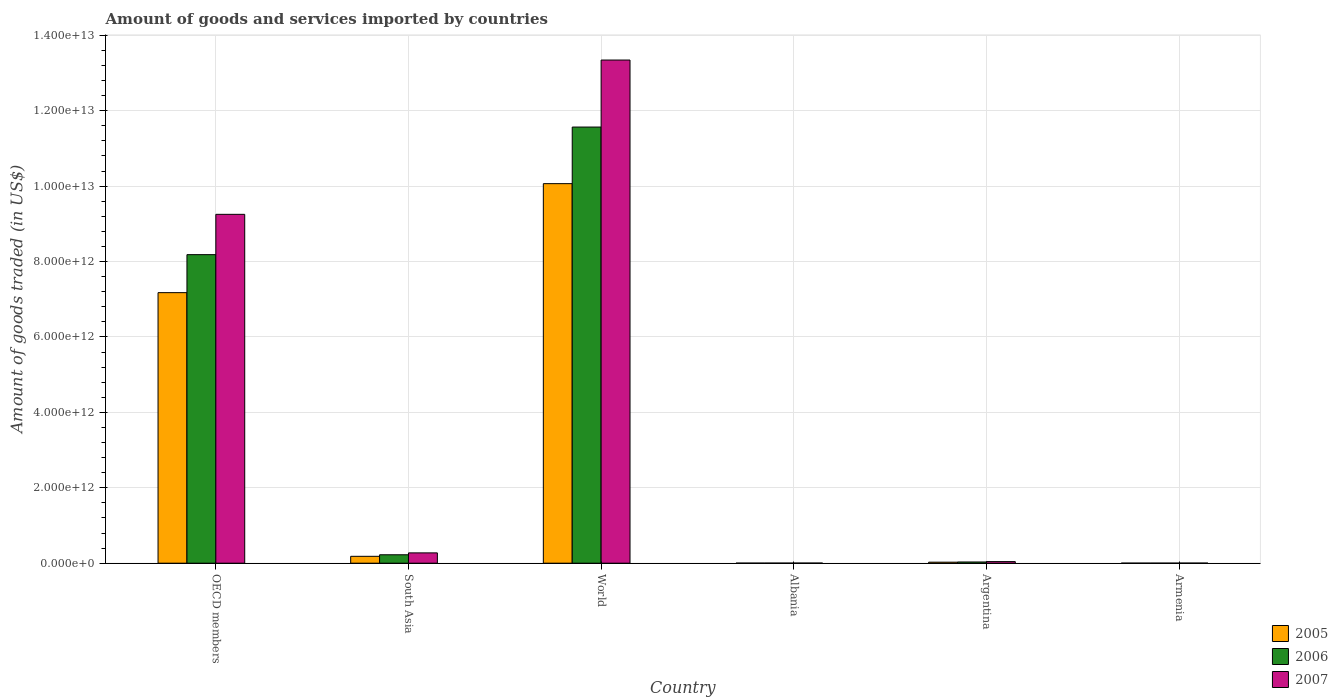How many bars are there on the 5th tick from the right?
Ensure brevity in your answer.  3. What is the label of the 4th group of bars from the left?
Give a very brief answer. Albania. In how many cases, is the number of bars for a given country not equal to the number of legend labels?
Your response must be concise. 0. What is the total amount of goods and services imported in 2007 in World?
Your answer should be compact. 1.33e+13. Across all countries, what is the maximum total amount of goods and services imported in 2007?
Provide a short and direct response. 1.33e+13. Across all countries, what is the minimum total amount of goods and services imported in 2007?
Keep it short and to the point. 2.92e+09. In which country was the total amount of goods and services imported in 2007 maximum?
Make the answer very short. World. In which country was the total amount of goods and services imported in 2007 minimum?
Ensure brevity in your answer.  Armenia. What is the total total amount of goods and services imported in 2005 in the graph?
Make the answer very short. 1.75e+13. What is the difference between the total amount of goods and services imported in 2007 in Albania and that in World?
Your answer should be compact. -1.33e+13. What is the difference between the total amount of goods and services imported in 2006 in Argentina and the total amount of goods and services imported in 2007 in South Asia?
Your answer should be very brief. -2.41e+11. What is the average total amount of goods and services imported in 2007 per country?
Your answer should be compact. 3.82e+12. What is the difference between the total amount of goods and services imported of/in 2005 and total amount of goods and services imported of/in 2006 in OECD members?
Keep it short and to the point. -1.01e+12. What is the ratio of the total amount of goods and services imported in 2006 in Albania to that in Argentina?
Provide a short and direct response. 0.08. Is the difference between the total amount of goods and services imported in 2005 in Argentina and South Asia greater than the difference between the total amount of goods and services imported in 2006 in Argentina and South Asia?
Keep it short and to the point. Yes. What is the difference between the highest and the second highest total amount of goods and services imported in 2005?
Ensure brevity in your answer.  -9.88e+12. What is the difference between the highest and the lowest total amount of goods and services imported in 2006?
Keep it short and to the point. 1.16e+13. Is the sum of the total amount of goods and services imported in 2005 in Argentina and Armenia greater than the maximum total amount of goods and services imported in 2007 across all countries?
Provide a short and direct response. No. Is it the case that in every country, the sum of the total amount of goods and services imported in 2005 and total amount of goods and services imported in 2007 is greater than the total amount of goods and services imported in 2006?
Give a very brief answer. Yes. What is the difference between two consecutive major ticks on the Y-axis?
Ensure brevity in your answer.  2.00e+12. Are the values on the major ticks of Y-axis written in scientific E-notation?
Give a very brief answer. Yes. Does the graph contain any zero values?
Offer a very short reply. No. Does the graph contain grids?
Keep it short and to the point. Yes. Where does the legend appear in the graph?
Keep it short and to the point. Bottom right. How many legend labels are there?
Your answer should be compact. 3. How are the legend labels stacked?
Offer a terse response. Vertical. What is the title of the graph?
Offer a terse response. Amount of goods and services imported by countries. What is the label or title of the Y-axis?
Give a very brief answer. Amount of goods traded (in US$). What is the Amount of goods traded (in US$) in 2005 in OECD members?
Your answer should be very brief. 7.18e+12. What is the Amount of goods traded (in US$) in 2006 in OECD members?
Make the answer very short. 8.18e+12. What is the Amount of goods traded (in US$) of 2007 in OECD members?
Offer a terse response. 9.25e+12. What is the Amount of goods traded (in US$) of 2005 in South Asia?
Ensure brevity in your answer.  1.83e+11. What is the Amount of goods traded (in US$) in 2006 in South Asia?
Ensure brevity in your answer.  2.24e+11. What is the Amount of goods traded (in US$) of 2007 in South Asia?
Offer a very short reply. 2.74e+11. What is the Amount of goods traded (in US$) of 2005 in World?
Provide a succinct answer. 1.01e+13. What is the Amount of goods traded (in US$) of 2006 in World?
Your answer should be compact. 1.16e+13. What is the Amount of goods traded (in US$) in 2007 in World?
Offer a very short reply. 1.33e+13. What is the Amount of goods traded (in US$) of 2005 in Albania?
Provide a succinct answer. 2.12e+09. What is the Amount of goods traded (in US$) of 2006 in Albania?
Keep it short and to the point. 2.50e+09. What is the Amount of goods traded (in US$) in 2007 in Albania?
Ensure brevity in your answer.  3.42e+09. What is the Amount of goods traded (in US$) of 2005 in Argentina?
Make the answer very short. 2.73e+1. What is the Amount of goods traded (in US$) in 2006 in Argentina?
Provide a succinct answer. 3.26e+1. What is the Amount of goods traded (in US$) of 2007 in Argentina?
Make the answer very short. 4.25e+1. What is the Amount of goods traded (in US$) in 2005 in Armenia?
Offer a terse response. 1.66e+09. What is the Amount of goods traded (in US$) in 2006 in Armenia?
Your answer should be very brief. 2.00e+09. What is the Amount of goods traded (in US$) of 2007 in Armenia?
Make the answer very short. 2.92e+09. Across all countries, what is the maximum Amount of goods traded (in US$) of 2005?
Provide a short and direct response. 1.01e+13. Across all countries, what is the maximum Amount of goods traded (in US$) of 2006?
Ensure brevity in your answer.  1.16e+13. Across all countries, what is the maximum Amount of goods traded (in US$) of 2007?
Your response must be concise. 1.33e+13. Across all countries, what is the minimum Amount of goods traded (in US$) of 2005?
Give a very brief answer. 1.66e+09. Across all countries, what is the minimum Amount of goods traded (in US$) of 2006?
Provide a succinct answer. 2.00e+09. Across all countries, what is the minimum Amount of goods traded (in US$) in 2007?
Provide a succinct answer. 2.92e+09. What is the total Amount of goods traded (in US$) of 2005 in the graph?
Give a very brief answer. 1.75e+13. What is the total Amount of goods traded (in US$) of 2006 in the graph?
Offer a terse response. 2.00e+13. What is the total Amount of goods traded (in US$) in 2007 in the graph?
Provide a short and direct response. 2.29e+13. What is the difference between the Amount of goods traded (in US$) in 2005 in OECD members and that in South Asia?
Your response must be concise. 6.99e+12. What is the difference between the Amount of goods traded (in US$) in 2006 in OECD members and that in South Asia?
Your answer should be very brief. 7.96e+12. What is the difference between the Amount of goods traded (in US$) in 2007 in OECD members and that in South Asia?
Give a very brief answer. 8.98e+12. What is the difference between the Amount of goods traded (in US$) of 2005 in OECD members and that in World?
Provide a succinct answer. -2.89e+12. What is the difference between the Amount of goods traded (in US$) of 2006 in OECD members and that in World?
Provide a short and direct response. -3.38e+12. What is the difference between the Amount of goods traded (in US$) in 2007 in OECD members and that in World?
Keep it short and to the point. -4.09e+12. What is the difference between the Amount of goods traded (in US$) in 2005 in OECD members and that in Albania?
Provide a succinct answer. 7.17e+12. What is the difference between the Amount of goods traded (in US$) of 2006 in OECD members and that in Albania?
Your answer should be very brief. 8.18e+12. What is the difference between the Amount of goods traded (in US$) in 2007 in OECD members and that in Albania?
Your answer should be compact. 9.25e+12. What is the difference between the Amount of goods traded (in US$) of 2005 in OECD members and that in Argentina?
Keep it short and to the point. 7.15e+12. What is the difference between the Amount of goods traded (in US$) in 2006 in OECD members and that in Argentina?
Make the answer very short. 8.15e+12. What is the difference between the Amount of goods traded (in US$) in 2007 in OECD members and that in Argentina?
Your answer should be compact. 9.21e+12. What is the difference between the Amount of goods traded (in US$) of 2005 in OECD members and that in Armenia?
Your answer should be very brief. 7.17e+12. What is the difference between the Amount of goods traded (in US$) in 2006 in OECD members and that in Armenia?
Give a very brief answer. 8.18e+12. What is the difference between the Amount of goods traded (in US$) of 2007 in OECD members and that in Armenia?
Make the answer very short. 9.25e+12. What is the difference between the Amount of goods traded (in US$) in 2005 in South Asia and that in World?
Make the answer very short. -9.88e+12. What is the difference between the Amount of goods traded (in US$) in 2006 in South Asia and that in World?
Provide a short and direct response. -1.13e+13. What is the difference between the Amount of goods traded (in US$) in 2007 in South Asia and that in World?
Keep it short and to the point. -1.31e+13. What is the difference between the Amount of goods traded (in US$) in 2005 in South Asia and that in Albania?
Provide a succinct answer. 1.81e+11. What is the difference between the Amount of goods traded (in US$) of 2006 in South Asia and that in Albania?
Your answer should be compact. 2.21e+11. What is the difference between the Amount of goods traded (in US$) of 2007 in South Asia and that in Albania?
Your answer should be compact. 2.70e+11. What is the difference between the Amount of goods traded (in US$) in 2005 in South Asia and that in Argentina?
Your response must be concise. 1.55e+11. What is the difference between the Amount of goods traded (in US$) of 2006 in South Asia and that in Argentina?
Your response must be concise. 1.91e+11. What is the difference between the Amount of goods traded (in US$) of 2007 in South Asia and that in Argentina?
Provide a short and direct response. 2.31e+11. What is the difference between the Amount of goods traded (in US$) of 2005 in South Asia and that in Armenia?
Your answer should be compact. 1.81e+11. What is the difference between the Amount of goods traded (in US$) in 2006 in South Asia and that in Armenia?
Offer a very short reply. 2.22e+11. What is the difference between the Amount of goods traded (in US$) in 2007 in South Asia and that in Armenia?
Give a very brief answer. 2.71e+11. What is the difference between the Amount of goods traded (in US$) in 2005 in World and that in Albania?
Your answer should be very brief. 1.01e+13. What is the difference between the Amount of goods traded (in US$) in 2006 in World and that in Albania?
Keep it short and to the point. 1.16e+13. What is the difference between the Amount of goods traded (in US$) in 2007 in World and that in Albania?
Keep it short and to the point. 1.33e+13. What is the difference between the Amount of goods traded (in US$) of 2005 in World and that in Argentina?
Provide a succinct answer. 1.00e+13. What is the difference between the Amount of goods traded (in US$) of 2006 in World and that in Argentina?
Provide a succinct answer. 1.15e+13. What is the difference between the Amount of goods traded (in US$) of 2007 in World and that in Argentina?
Offer a terse response. 1.33e+13. What is the difference between the Amount of goods traded (in US$) of 2005 in World and that in Armenia?
Ensure brevity in your answer.  1.01e+13. What is the difference between the Amount of goods traded (in US$) of 2006 in World and that in Armenia?
Your answer should be very brief. 1.16e+13. What is the difference between the Amount of goods traded (in US$) of 2007 in World and that in Armenia?
Make the answer very short. 1.33e+13. What is the difference between the Amount of goods traded (in US$) in 2005 in Albania and that in Argentina?
Offer a very short reply. -2.52e+1. What is the difference between the Amount of goods traded (in US$) of 2006 in Albania and that in Argentina?
Make the answer very short. -3.01e+1. What is the difference between the Amount of goods traded (in US$) in 2007 in Albania and that in Argentina?
Your answer should be very brief. -3.91e+1. What is the difference between the Amount of goods traded (in US$) in 2005 in Albania and that in Armenia?
Provide a short and direct response. 4.54e+08. What is the difference between the Amount of goods traded (in US$) of 2006 in Albania and that in Armenia?
Give a very brief answer. 5.00e+08. What is the difference between the Amount of goods traded (in US$) in 2007 in Albania and that in Armenia?
Your answer should be very brief. 4.99e+08. What is the difference between the Amount of goods traded (in US$) of 2005 in Argentina and that in Armenia?
Your response must be concise. 2.56e+1. What is the difference between the Amount of goods traded (in US$) of 2006 in Argentina and that in Armenia?
Provide a short and direct response. 3.06e+1. What is the difference between the Amount of goods traded (in US$) in 2007 in Argentina and that in Armenia?
Provide a short and direct response. 3.96e+1. What is the difference between the Amount of goods traded (in US$) of 2005 in OECD members and the Amount of goods traded (in US$) of 2006 in South Asia?
Your response must be concise. 6.95e+12. What is the difference between the Amount of goods traded (in US$) of 2005 in OECD members and the Amount of goods traded (in US$) of 2007 in South Asia?
Offer a terse response. 6.90e+12. What is the difference between the Amount of goods traded (in US$) of 2006 in OECD members and the Amount of goods traded (in US$) of 2007 in South Asia?
Your response must be concise. 7.91e+12. What is the difference between the Amount of goods traded (in US$) of 2005 in OECD members and the Amount of goods traded (in US$) of 2006 in World?
Keep it short and to the point. -4.39e+12. What is the difference between the Amount of goods traded (in US$) in 2005 in OECD members and the Amount of goods traded (in US$) in 2007 in World?
Your answer should be very brief. -6.17e+12. What is the difference between the Amount of goods traded (in US$) in 2006 in OECD members and the Amount of goods traded (in US$) in 2007 in World?
Keep it short and to the point. -5.16e+12. What is the difference between the Amount of goods traded (in US$) of 2005 in OECD members and the Amount of goods traded (in US$) of 2006 in Albania?
Offer a very short reply. 7.17e+12. What is the difference between the Amount of goods traded (in US$) in 2005 in OECD members and the Amount of goods traded (in US$) in 2007 in Albania?
Provide a short and direct response. 7.17e+12. What is the difference between the Amount of goods traded (in US$) of 2006 in OECD members and the Amount of goods traded (in US$) of 2007 in Albania?
Give a very brief answer. 8.18e+12. What is the difference between the Amount of goods traded (in US$) of 2005 in OECD members and the Amount of goods traded (in US$) of 2006 in Argentina?
Make the answer very short. 7.14e+12. What is the difference between the Amount of goods traded (in US$) of 2005 in OECD members and the Amount of goods traded (in US$) of 2007 in Argentina?
Give a very brief answer. 7.13e+12. What is the difference between the Amount of goods traded (in US$) in 2006 in OECD members and the Amount of goods traded (in US$) in 2007 in Argentina?
Your response must be concise. 8.14e+12. What is the difference between the Amount of goods traded (in US$) of 2005 in OECD members and the Amount of goods traded (in US$) of 2006 in Armenia?
Ensure brevity in your answer.  7.17e+12. What is the difference between the Amount of goods traded (in US$) of 2005 in OECD members and the Amount of goods traded (in US$) of 2007 in Armenia?
Make the answer very short. 7.17e+12. What is the difference between the Amount of goods traded (in US$) of 2006 in OECD members and the Amount of goods traded (in US$) of 2007 in Armenia?
Provide a short and direct response. 8.18e+12. What is the difference between the Amount of goods traded (in US$) in 2005 in South Asia and the Amount of goods traded (in US$) in 2006 in World?
Make the answer very short. -1.14e+13. What is the difference between the Amount of goods traded (in US$) in 2005 in South Asia and the Amount of goods traded (in US$) in 2007 in World?
Ensure brevity in your answer.  -1.32e+13. What is the difference between the Amount of goods traded (in US$) in 2006 in South Asia and the Amount of goods traded (in US$) in 2007 in World?
Provide a short and direct response. -1.31e+13. What is the difference between the Amount of goods traded (in US$) of 2005 in South Asia and the Amount of goods traded (in US$) of 2006 in Albania?
Offer a terse response. 1.80e+11. What is the difference between the Amount of goods traded (in US$) of 2005 in South Asia and the Amount of goods traded (in US$) of 2007 in Albania?
Provide a succinct answer. 1.79e+11. What is the difference between the Amount of goods traded (in US$) of 2006 in South Asia and the Amount of goods traded (in US$) of 2007 in Albania?
Provide a short and direct response. 2.20e+11. What is the difference between the Amount of goods traded (in US$) of 2005 in South Asia and the Amount of goods traded (in US$) of 2006 in Argentina?
Make the answer very short. 1.50e+11. What is the difference between the Amount of goods traded (in US$) in 2005 in South Asia and the Amount of goods traded (in US$) in 2007 in Argentina?
Provide a succinct answer. 1.40e+11. What is the difference between the Amount of goods traded (in US$) in 2006 in South Asia and the Amount of goods traded (in US$) in 2007 in Argentina?
Offer a terse response. 1.81e+11. What is the difference between the Amount of goods traded (in US$) of 2005 in South Asia and the Amount of goods traded (in US$) of 2006 in Armenia?
Give a very brief answer. 1.81e+11. What is the difference between the Amount of goods traded (in US$) of 2005 in South Asia and the Amount of goods traded (in US$) of 2007 in Armenia?
Make the answer very short. 1.80e+11. What is the difference between the Amount of goods traded (in US$) of 2006 in South Asia and the Amount of goods traded (in US$) of 2007 in Armenia?
Your response must be concise. 2.21e+11. What is the difference between the Amount of goods traded (in US$) in 2005 in World and the Amount of goods traded (in US$) in 2006 in Albania?
Offer a terse response. 1.01e+13. What is the difference between the Amount of goods traded (in US$) in 2005 in World and the Amount of goods traded (in US$) in 2007 in Albania?
Provide a short and direct response. 1.01e+13. What is the difference between the Amount of goods traded (in US$) of 2006 in World and the Amount of goods traded (in US$) of 2007 in Albania?
Offer a very short reply. 1.16e+13. What is the difference between the Amount of goods traded (in US$) in 2005 in World and the Amount of goods traded (in US$) in 2006 in Argentina?
Offer a terse response. 1.00e+13. What is the difference between the Amount of goods traded (in US$) in 2005 in World and the Amount of goods traded (in US$) in 2007 in Argentina?
Provide a short and direct response. 1.00e+13. What is the difference between the Amount of goods traded (in US$) of 2006 in World and the Amount of goods traded (in US$) of 2007 in Argentina?
Offer a very short reply. 1.15e+13. What is the difference between the Amount of goods traded (in US$) in 2005 in World and the Amount of goods traded (in US$) in 2006 in Armenia?
Make the answer very short. 1.01e+13. What is the difference between the Amount of goods traded (in US$) in 2005 in World and the Amount of goods traded (in US$) in 2007 in Armenia?
Give a very brief answer. 1.01e+13. What is the difference between the Amount of goods traded (in US$) of 2006 in World and the Amount of goods traded (in US$) of 2007 in Armenia?
Make the answer very short. 1.16e+13. What is the difference between the Amount of goods traded (in US$) in 2005 in Albania and the Amount of goods traded (in US$) in 2006 in Argentina?
Your answer should be compact. -3.05e+1. What is the difference between the Amount of goods traded (in US$) in 2005 in Albania and the Amount of goods traded (in US$) in 2007 in Argentina?
Give a very brief answer. -4.04e+1. What is the difference between the Amount of goods traded (in US$) of 2006 in Albania and the Amount of goods traded (in US$) of 2007 in Argentina?
Provide a succinct answer. -4.00e+1. What is the difference between the Amount of goods traded (in US$) in 2005 in Albania and the Amount of goods traded (in US$) in 2006 in Armenia?
Your response must be concise. 1.18e+08. What is the difference between the Amount of goods traded (in US$) of 2005 in Albania and the Amount of goods traded (in US$) of 2007 in Armenia?
Provide a succinct answer. -8.04e+08. What is the difference between the Amount of goods traded (in US$) in 2006 in Albania and the Amount of goods traded (in US$) in 2007 in Armenia?
Provide a succinct answer. -4.21e+08. What is the difference between the Amount of goods traded (in US$) in 2005 in Argentina and the Amount of goods traded (in US$) in 2006 in Armenia?
Offer a terse response. 2.53e+1. What is the difference between the Amount of goods traded (in US$) in 2005 in Argentina and the Amount of goods traded (in US$) in 2007 in Armenia?
Offer a terse response. 2.44e+1. What is the difference between the Amount of goods traded (in US$) of 2006 in Argentina and the Amount of goods traded (in US$) of 2007 in Armenia?
Provide a succinct answer. 2.97e+1. What is the average Amount of goods traded (in US$) in 2005 per country?
Provide a short and direct response. 2.91e+12. What is the average Amount of goods traded (in US$) of 2006 per country?
Your response must be concise. 3.34e+12. What is the average Amount of goods traded (in US$) of 2007 per country?
Make the answer very short. 3.82e+12. What is the difference between the Amount of goods traded (in US$) in 2005 and Amount of goods traded (in US$) in 2006 in OECD members?
Provide a succinct answer. -1.01e+12. What is the difference between the Amount of goods traded (in US$) of 2005 and Amount of goods traded (in US$) of 2007 in OECD members?
Make the answer very short. -2.08e+12. What is the difference between the Amount of goods traded (in US$) of 2006 and Amount of goods traded (in US$) of 2007 in OECD members?
Provide a short and direct response. -1.07e+12. What is the difference between the Amount of goods traded (in US$) in 2005 and Amount of goods traded (in US$) in 2006 in South Asia?
Ensure brevity in your answer.  -4.10e+1. What is the difference between the Amount of goods traded (in US$) in 2005 and Amount of goods traded (in US$) in 2007 in South Asia?
Offer a terse response. -9.08e+1. What is the difference between the Amount of goods traded (in US$) in 2006 and Amount of goods traded (in US$) in 2007 in South Asia?
Give a very brief answer. -4.98e+1. What is the difference between the Amount of goods traded (in US$) in 2005 and Amount of goods traded (in US$) in 2006 in World?
Make the answer very short. -1.50e+12. What is the difference between the Amount of goods traded (in US$) in 2005 and Amount of goods traded (in US$) in 2007 in World?
Provide a succinct answer. -3.28e+12. What is the difference between the Amount of goods traded (in US$) of 2006 and Amount of goods traded (in US$) of 2007 in World?
Offer a terse response. -1.78e+12. What is the difference between the Amount of goods traded (in US$) in 2005 and Amount of goods traded (in US$) in 2006 in Albania?
Provide a succinct answer. -3.82e+08. What is the difference between the Amount of goods traded (in US$) in 2005 and Amount of goods traded (in US$) in 2007 in Albania?
Provide a succinct answer. -1.30e+09. What is the difference between the Amount of goods traded (in US$) of 2006 and Amount of goods traded (in US$) of 2007 in Albania?
Your response must be concise. -9.20e+08. What is the difference between the Amount of goods traded (in US$) in 2005 and Amount of goods traded (in US$) in 2006 in Argentina?
Offer a very short reply. -5.29e+09. What is the difference between the Amount of goods traded (in US$) in 2005 and Amount of goods traded (in US$) in 2007 in Argentina?
Offer a terse response. -1.52e+1. What is the difference between the Amount of goods traded (in US$) of 2006 and Amount of goods traded (in US$) of 2007 in Argentina?
Provide a short and direct response. -9.94e+09. What is the difference between the Amount of goods traded (in US$) of 2005 and Amount of goods traded (in US$) of 2006 in Armenia?
Ensure brevity in your answer.  -3.37e+08. What is the difference between the Amount of goods traded (in US$) of 2005 and Amount of goods traded (in US$) of 2007 in Armenia?
Your answer should be very brief. -1.26e+09. What is the difference between the Amount of goods traded (in US$) of 2006 and Amount of goods traded (in US$) of 2007 in Armenia?
Keep it short and to the point. -9.21e+08. What is the ratio of the Amount of goods traded (in US$) of 2005 in OECD members to that in South Asia?
Offer a terse response. 39.28. What is the ratio of the Amount of goods traded (in US$) of 2006 in OECD members to that in South Asia?
Make the answer very short. 36.58. What is the ratio of the Amount of goods traded (in US$) in 2007 in OECD members to that in South Asia?
Keep it short and to the point. 33.83. What is the ratio of the Amount of goods traded (in US$) in 2005 in OECD members to that in World?
Offer a terse response. 0.71. What is the ratio of the Amount of goods traded (in US$) of 2006 in OECD members to that in World?
Provide a short and direct response. 0.71. What is the ratio of the Amount of goods traded (in US$) in 2007 in OECD members to that in World?
Give a very brief answer. 0.69. What is the ratio of the Amount of goods traded (in US$) in 2005 in OECD members to that in Albania?
Offer a terse response. 3388.67. What is the ratio of the Amount of goods traded (in US$) of 2006 in OECD members to that in Albania?
Offer a terse response. 3273.5. What is the ratio of the Amount of goods traded (in US$) in 2007 in OECD members to that in Albania?
Provide a short and direct response. 2705.56. What is the ratio of the Amount of goods traded (in US$) in 2005 in OECD members to that in Argentina?
Offer a terse response. 262.83. What is the ratio of the Amount of goods traded (in US$) of 2006 in OECD members to that in Argentina?
Give a very brief answer. 251.1. What is the ratio of the Amount of goods traded (in US$) of 2007 in OECD members to that in Argentina?
Make the answer very short. 217.57. What is the ratio of the Amount of goods traded (in US$) in 2005 in OECD members to that in Armenia?
Keep it short and to the point. 4313.75. What is the ratio of the Amount of goods traded (in US$) in 2006 in OECD members to that in Armenia?
Your answer should be compact. 4091.62. What is the ratio of the Amount of goods traded (in US$) in 2007 in OECD members to that in Armenia?
Provide a succinct answer. 3167.37. What is the ratio of the Amount of goods traded (in US$) in 2005 in South Asia to that in World?
Your response must be concise. 0.02. What is the ratio of the Amount of goods traded (in US$) of 2006 in South Asia to that in World?
Ensure brevity in your answer.  0.02. What is the ratio of the Amount of goods traded (in US$) in 2007 in South Asia to that in World?
Make the answer very short. 0.02. What is the ratio of the Amount of goods traded (in US$) in 2005 in South Asia to that in Albania?
Offer a terse response. 86.28. What is the ratio of the Amount of goods traded (in US$) of 2006 in South Asia to that in Albania?
Offer a terse response. 89.49. What is the ratio of the Amount of goods traded (in US$) in 2007 in South Asia to that in Albania?
Offer a terse response. 79.98. What is the ratio of the Amount of goods traded (in US$) of 2005 in South Asia to that in Argentina?
Your answer should be very brief. 6.69. What is the ratio of the Amount of goods traded (in US$) of 2006 in South Asia to that in Argentina?
Provide a succinct answer. 6.86. What is the ratio of the Amount of goods traded (in US$) of 2007 in South Asia to that in Argentina?
Ensure brevity in your answer.  6.43. What is the ratio of the Amount of goods traded (in US$) in 2005 in South Asia to that in Armenia?
Provide a short and direct response. 109.83. What is the ratio of the Amount of goods traded (in US$) in 2006 in South Asia to that in Armenia?
Your response must be concise. 111.86. What is the ratio of the Amount of goods traded (in US$) of 2007 in South Asia to that in Armenia?
Give a very brief answer. 93.64. What is the ratio of the Amount of goods traded (in US$) in 2005 in World to that in Albania?
Offer a terse response. 4753.81. What is the ratio of the Amount of goods traded (in US$) in 2006 in World to that in Albania?
Offer a very short reply. 4627.15. What is the ratio of the Amount of goods traded (in US$) of 2007 in World to that in Albania?
Your answer should be very brief. 3902.19. What is the ratio of the Amount of goods traded (in US$) of 2005 in World to that in Argentina?
Make the answer very short. 368.72. What is the ratio of the Amount of goods traded (in US$) in 2006 in World to that in Argentina?
Give a very brief answer. 354.94. What is the ratio of the Amount of goods traded (in US$) in 2007 in World to that in Argentina?
Your answer should be compact. 313.8. What is the ratio of the Amount of goods traded (in US$) in 2005 in World to that in Armenia?
Offer a terse response. 6051.57. What is the ratio of the Amount of goods traded (in US$) of 2006 in World to that in Armenia?
Provide a succinct answer. 5783.57. What is the ratio of the Amount of goods traded (in US$) of 2007 in World to that in Armenia?
Your response must be concise. 4568.25. What is the ratio of the Amount of goods traded (in US$) of 2005 in Albania to that in Argentina?
Keep it short and to the point. 0.08. What is the ratio of the Amount of goods traded (in US$) in 2006 in Albania to that in Argentina?
Your response must be concise. 0.08. What is the ratio of the Amount of goods traded (in US$) in 2007 in Albania to that in Argentina?
Your response must be concise. 0.08. What is the ratio of the Amount of goods traded (in US$) in 2005 in Albania to that in Armenia?
Offer a very short reply. 1.27. What is the ratio of the Amount of goods traded (in US$) of 2006 in Albania to that in Armenia?
Provide a short and direct response. 1.25. What is the ratio of the Amount of goods traded (in US$) in 2007 in Albania to that in Armenia?
Your answer should be very brief. 1.17. What is the ratio of the Amount of goods traded (in US$) of 2005 in Argentina to that in Armenia?
Ensure brevity in your answer.  16.41. What is the ratio of the Amount of goods traded (in US$) of 2006 in Argentina to that in Armenia?
Your answer should be compact. 16.29. What is the ratio of the Amount of goods traded (in US$) in 2007 in Argentina to that in Armenia?
Offer a very short reply. 14.56. What is the difference between the highest and the second highest Amount of goods traded (in US$) of 2005?
Keep it short and to the point. 2.89e+12. What is the difference between the highest and the second highest Amount of goods traded (in US$) of 2006?
Provide a succinct answer. 3.38e+12. What is the difference between the highest and the second highest Amount of goods traded (in US$) in 2007?
Offer a very short reply. 4.09e+12. What is the difference between the highest and the lowest Amount of goods traded (in US$) in 2005?
Your answer should be compact. 1.01e+13. What is the difference between the highest and the lowest Amount of goods traded (in US$) of 2006?
Make the answer very short. 1.16e+13. What is the difference between the highest and the lowest Amount of goods traded (in US$) of 2007?
Provide a short and direct response. 1.33e+13. 